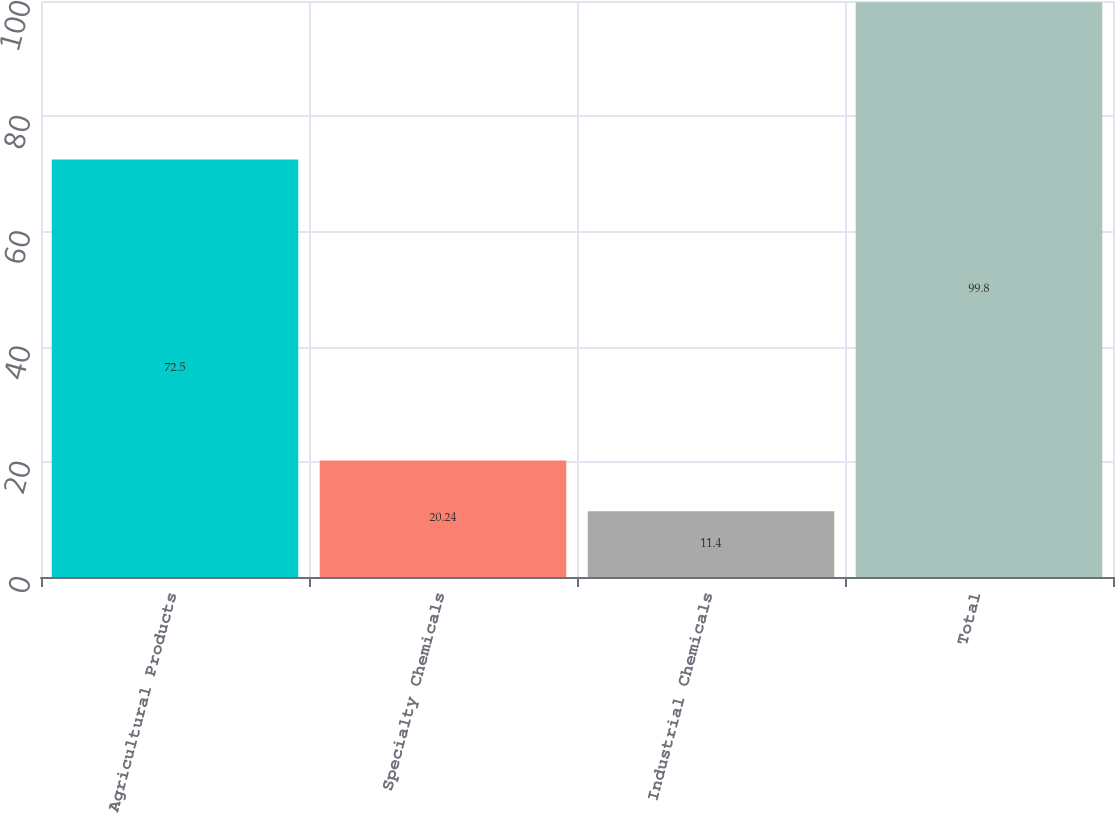Convert chart to OTSL. <chart><loc_0><loc_0><loc_500><loc_500><bar_chart><fcel>Agricultural Products<fcel>Specialty Chemicals<fcel>Industrial Chemicals<fcel>Total<nl><fcel>72.5<fcel>20.24<fcel>11.4<fcel>99.8<nl></chart> 